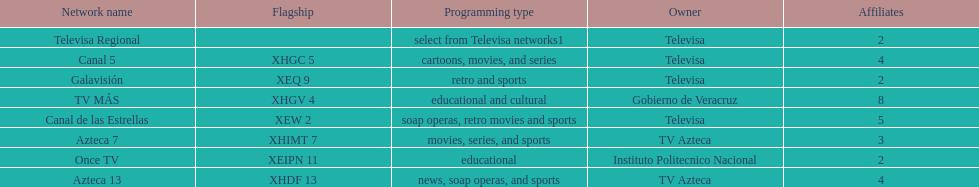Who has the most number of affiliates? TV MÁS. 